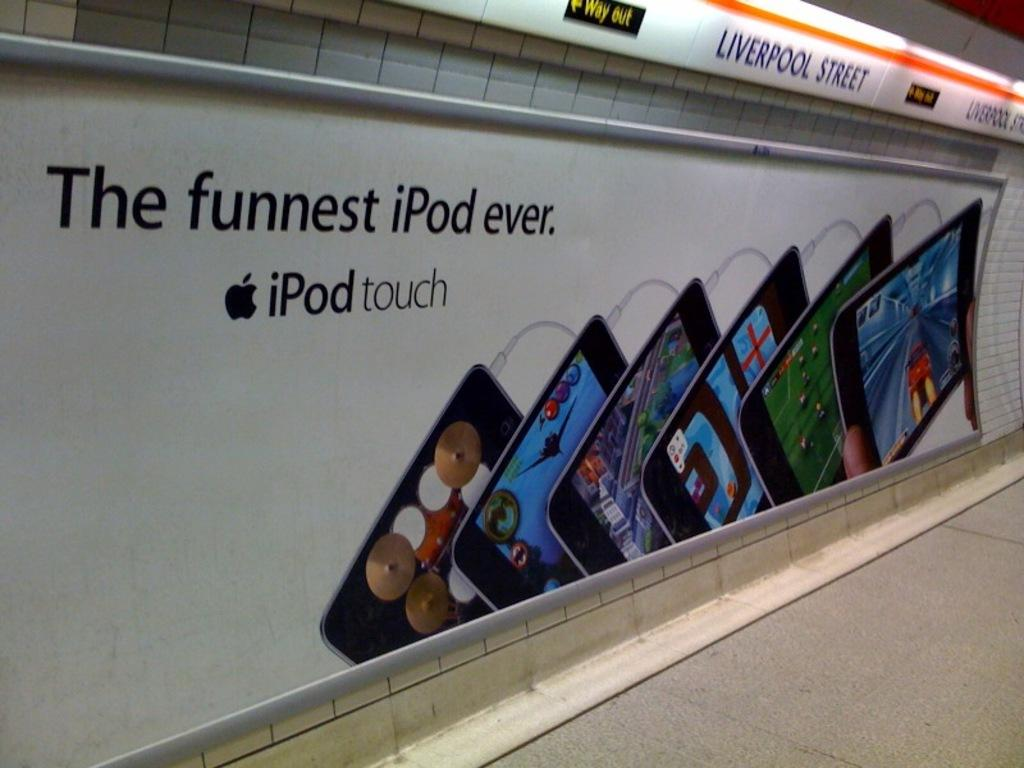<image>
Summarize the visual content of the image. Subway ad that says "The Funnest iPod Ever". 